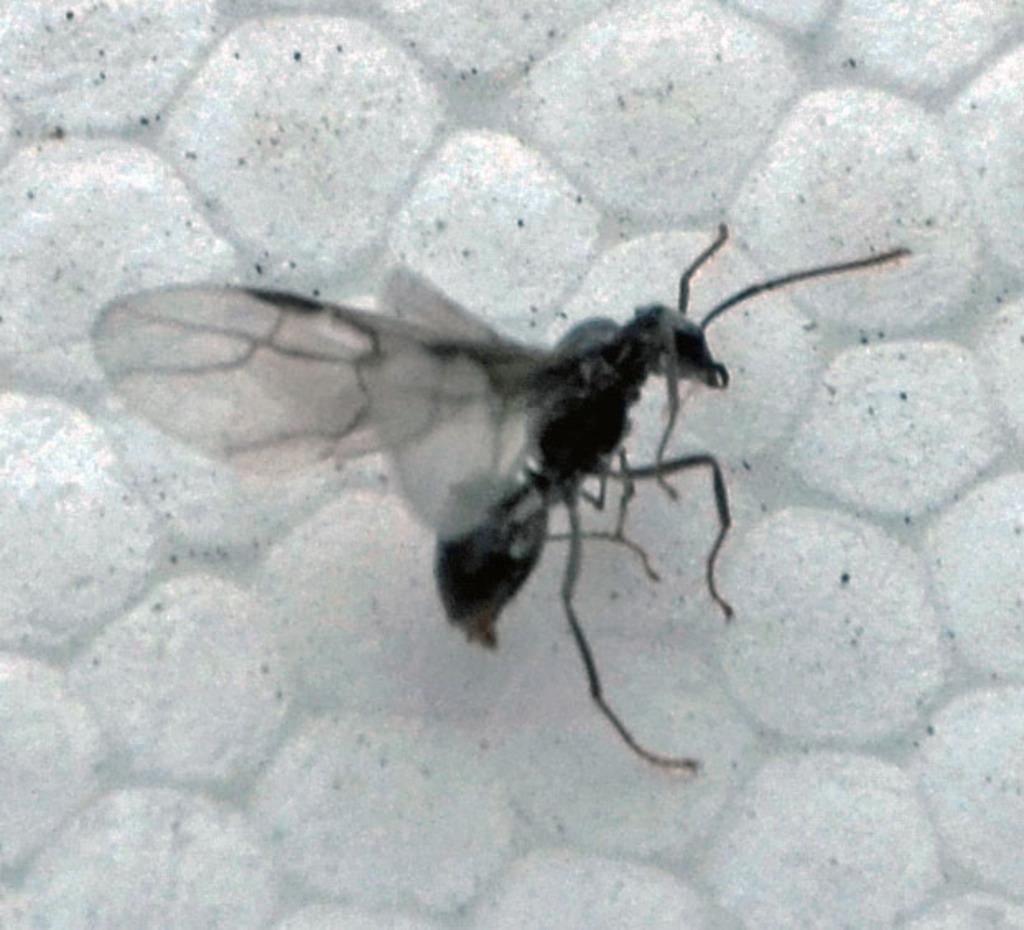What is the color scheme of the image? The image is black and white. What type of creature can be seen in the image? There is an insect in the image. What is the color of the insect? The insect is black in color. What is the insect resting on in the image? The insect is on a white object. Can you describe the sky in the image? There is no sky visible in the image, as it is black and white and focuses on an insect on a white object. How does the insect interact with the person in the image? There is no person present in the image, only an insect on a white object. 